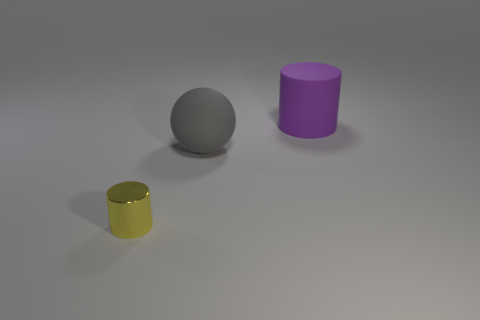How many purple rubber cylinders are behind the cylinder that is behind the yellow metallic thing? 0 